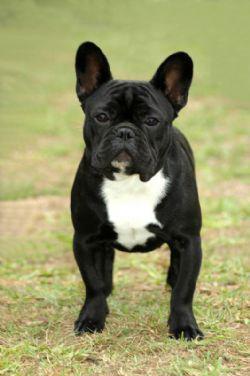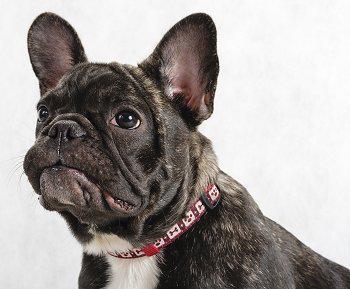The first image is the image on the left, the second image is the image on the right. For the images displayed, is the sentence "A dog is wearing a collar." factually correct? Answer yes or no. Yes. 